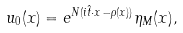Convert formula to latex. <formula><loc_0><loc_0><loc_500><loc_500>u _ { 0 } ( x ) = e ^ { N ( i \hat { t } \cdot x - \rho ( x ) ) } \eta _ { M } ( x ) ,</formula> 